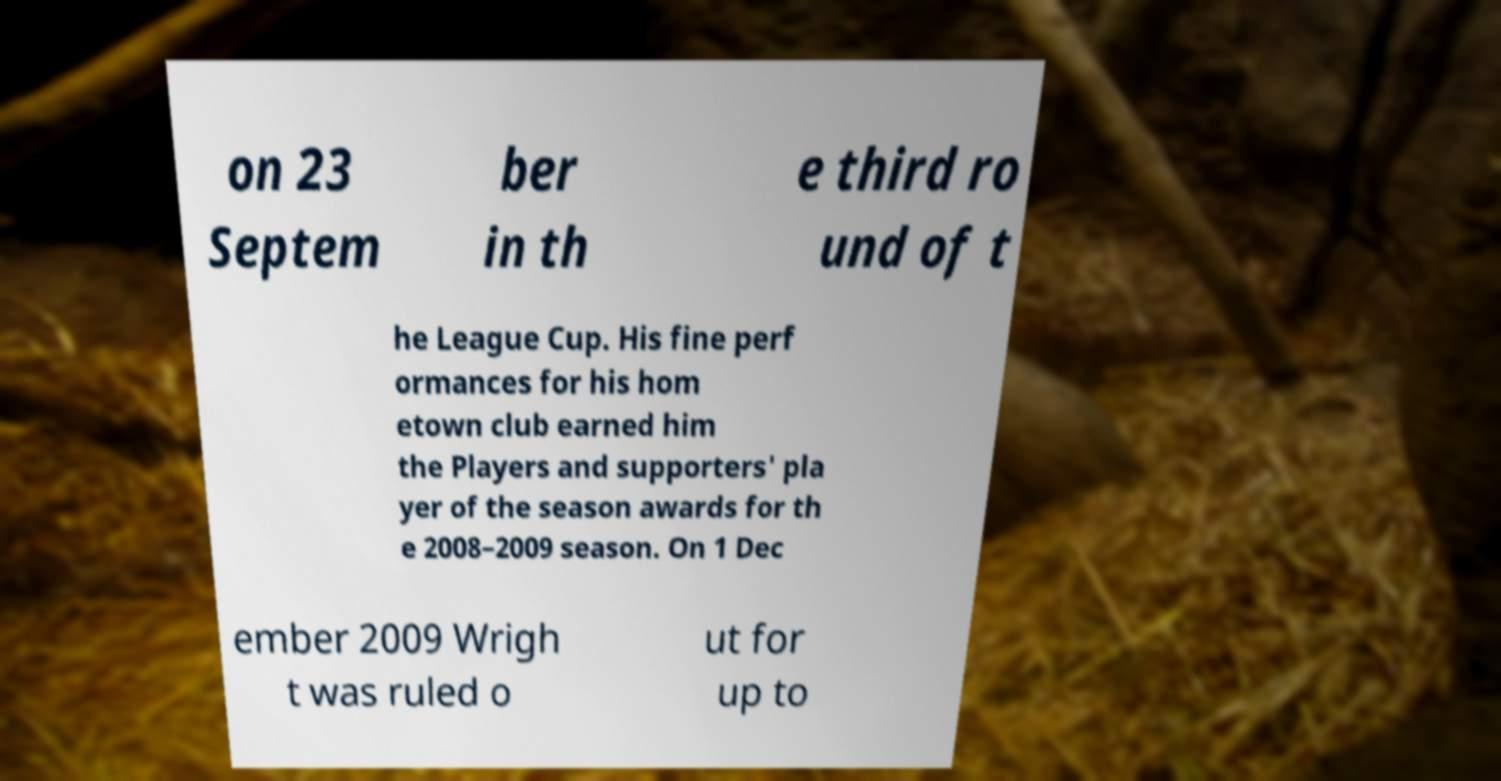There's text embedded in this image that I need extracted. Can you transcribe it verbatim? on 23 Septem ber in th e third ro und of t he League Cup. His fine perf ormances for his hom etown club earned him the Players and supporters' pla yer of the season awards for th e 2008–2009 season. On 1 Dec ember 2009 Wrigh t was ruled o ut for up to 